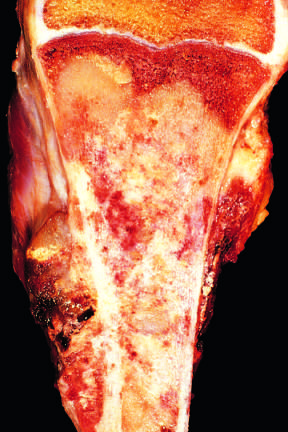does the tan-white tumor fill most of the medullary cavity of the metaphysis and proximal diaphysis?
Answer the question using a single word or phrase. Yes 